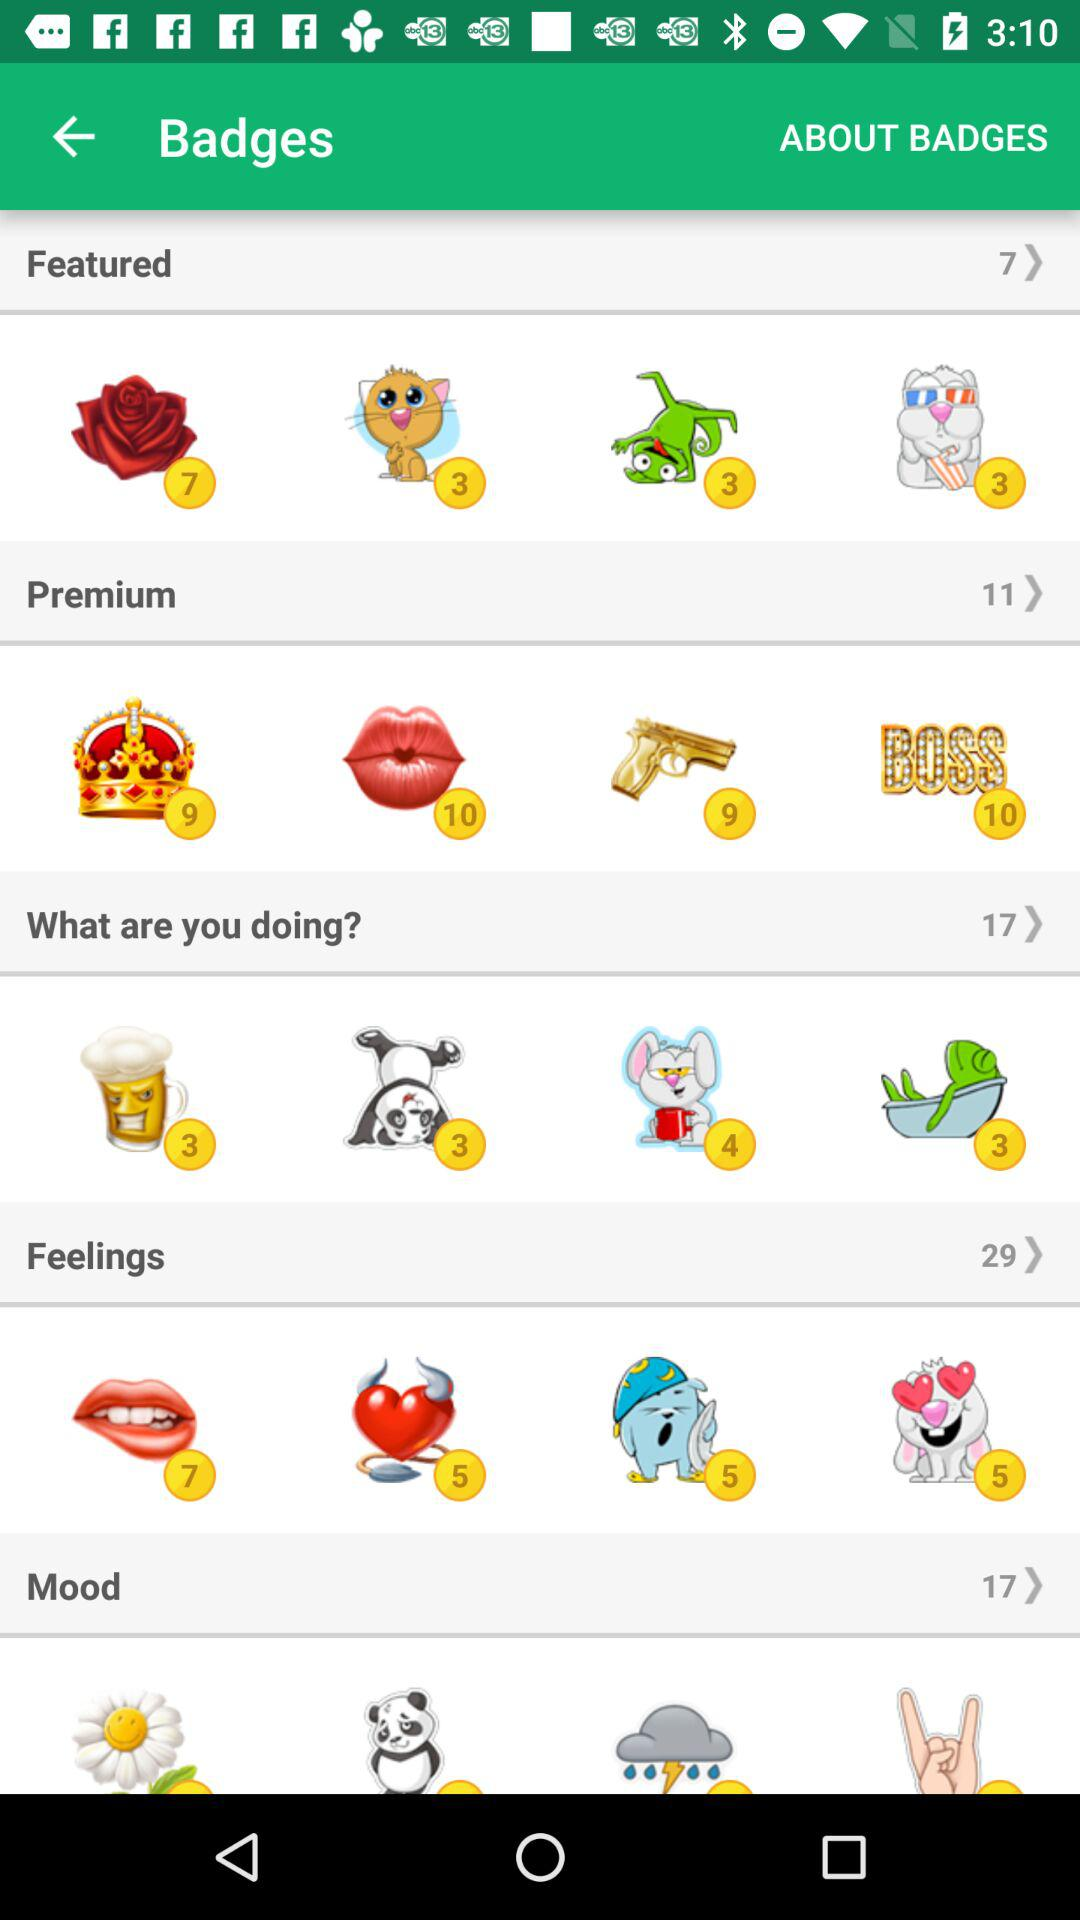What is the total number of featured stickers? The total number of featured stickers is 7. 